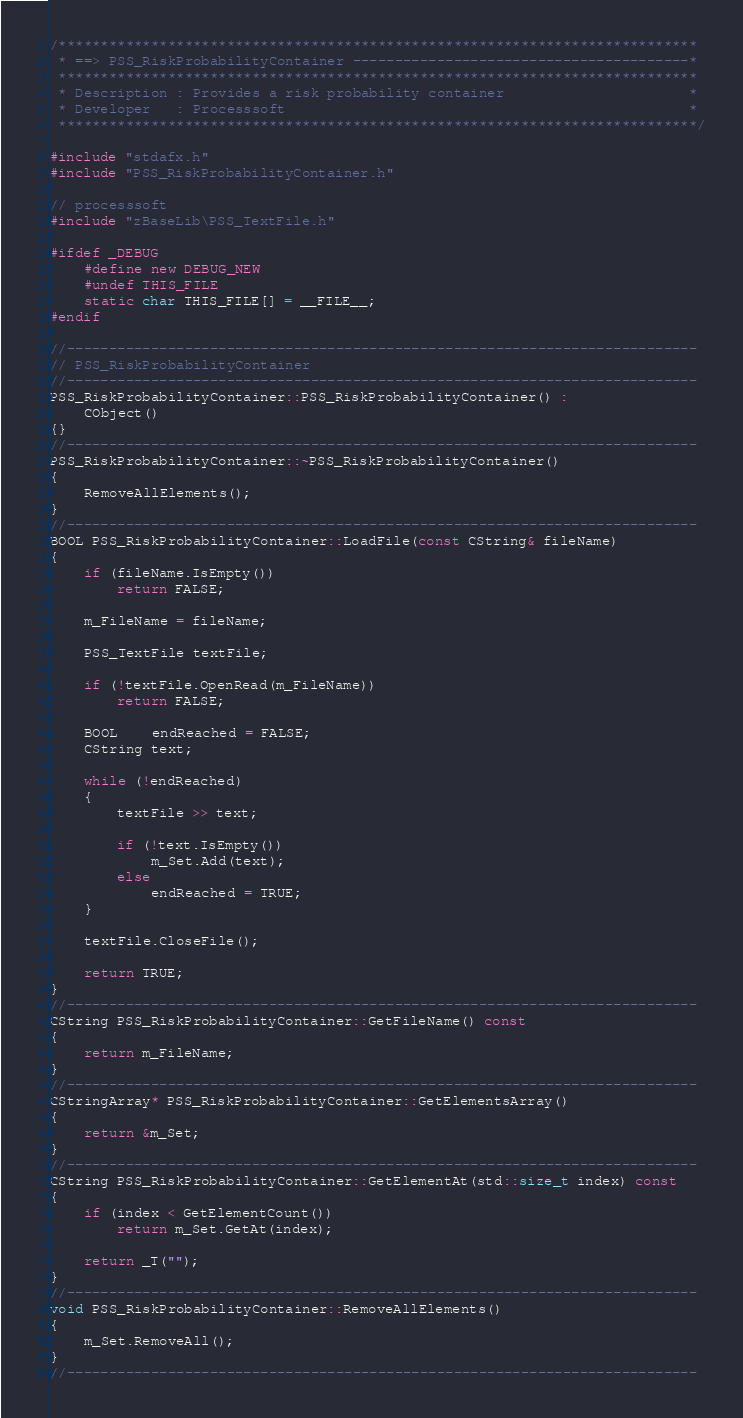<code> <loc_0><loc_0><loc_500><loc_500><_C++_>/****************************************************************************
 * ==> PSS_RiskProbabilityContainer ----------------------------------------*
 ****************************************************************************
 * Description : Provides a risk probability container                      *
 * Developer   : Processsoft                                                *
 ****************************************************************************/

#include "stdafx.h"
#include "PSS_RiskProbabilityContainer.h"

// processsoft
#include "zBaseLib\PSS_TextFile.h"

#ifdef _DEBUG
    #define new DEBUG_NEW
    #undef THIS_FILE
    static char THIS_FILE[] = __FILE__;
#endif

//---------------------------------------------------------------------------
// PSS_RiskProbabilityContainer
//---------------------------------------------------------------------------
PSS_RiskProbabilityContainer::PSS_RiskProbabilityContainer() :
    CObject()
{}
//---------------------------------------------------------------------------
PSS_RiskProbabilityContainer::~PSS_RiskProbabilityContainer()
{
    RemoveAllElements();
}
//---------------------------------------------------------------------------
BOOL PSS_RiskProbabilityContainer::LoadFile(const CString& fileName)
{
    if (fileName.IsEmpty())
        return FALSE;

    m_FileName = fileName;

    PSS_TextFile textFile;

    if (!textFile.OpenRead(m_FileName))
        return FALSE;

    BOOL    endReached = FALSE;
    CString text;

    while (!endReached)
    {
        textFile >> text;

        if (!text.IsEmpty())
            m_Set.Add(text);
        else
            endReached = TRUE;
    }

    textFile.CloseFile();

    return TRUE;
}
//---------------------------------------------------------------------------
CString PSS_RiskProbabilityContainer::GetFileName() const
{
    return m_FileName;
}
//---------------------------------------------------------------------------
CStringArray* PSS_RiskProbabilityContainer::GetElementsArray()
{
    return &m_Set;
}
//---------------------------------------------------------------------------
CString PSS_RiskProbabilityContainer::GetElementAt(std::size_t index) const
{
    if (index < GetElementCount())
        return m_Set.GetAt(index);

    return _T("");
}
//---------------------------------------------------------------------------
void PSS_RiskProbabilityContainer::RemoveAllElements()
{
    m_Set.RemoveAll();
}
//---------------------------------------------------------------------------
</code> 